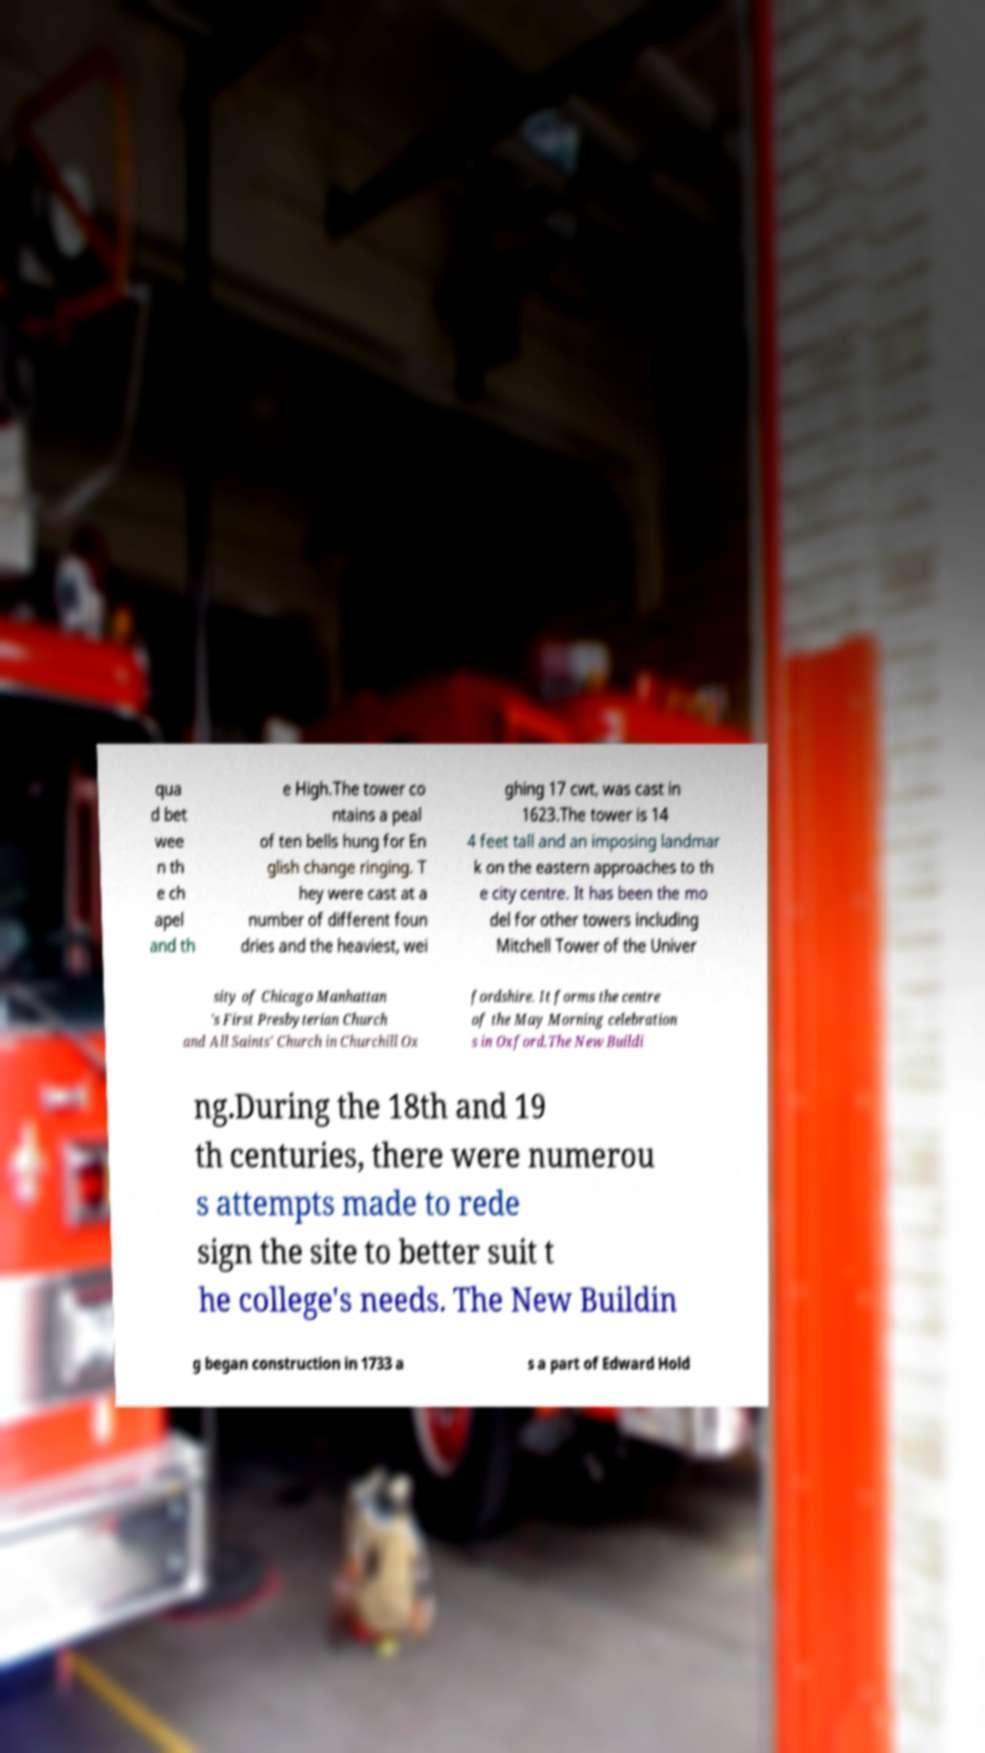Please identify and transcribe the text found in this image. qua d bet wee n th e ch apel and th e High.The tower co ntains a peal of ten bells hung for En glish change ringing. T hey were cast at a number of different foun dries and the heaviest, wei ghing 17 cwt, was cast in 1623.The tower is 14 4 feet tall and an imposing landmar k on the eastern approaches to th e city centre. It has been the mo del for other towers including Mitchell Tower of the Univer sity of Chicago Manhattan 's First Presbyterian Church and All Saints' Church in Churchill Ox fordshire. It forms the centre of the May Morning celebration s in Oxford.The New Buildi ng.During the 18th and 19 th centuries, there were numerou s attempts made to rede sign the site to better suit t he college's needs. The New Buildin g began construction in 1733 a s a part of Edward Hold 